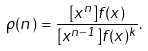Convert formula to latex. <formula><loc_0><loc_0><loc_500><loc_500>\rho ( n ) = \frac { [ x ^ { n } ] f ( x ) } { [ x ^ { n - 1 } ] f ( x ) ^ { k } } .</formula> 